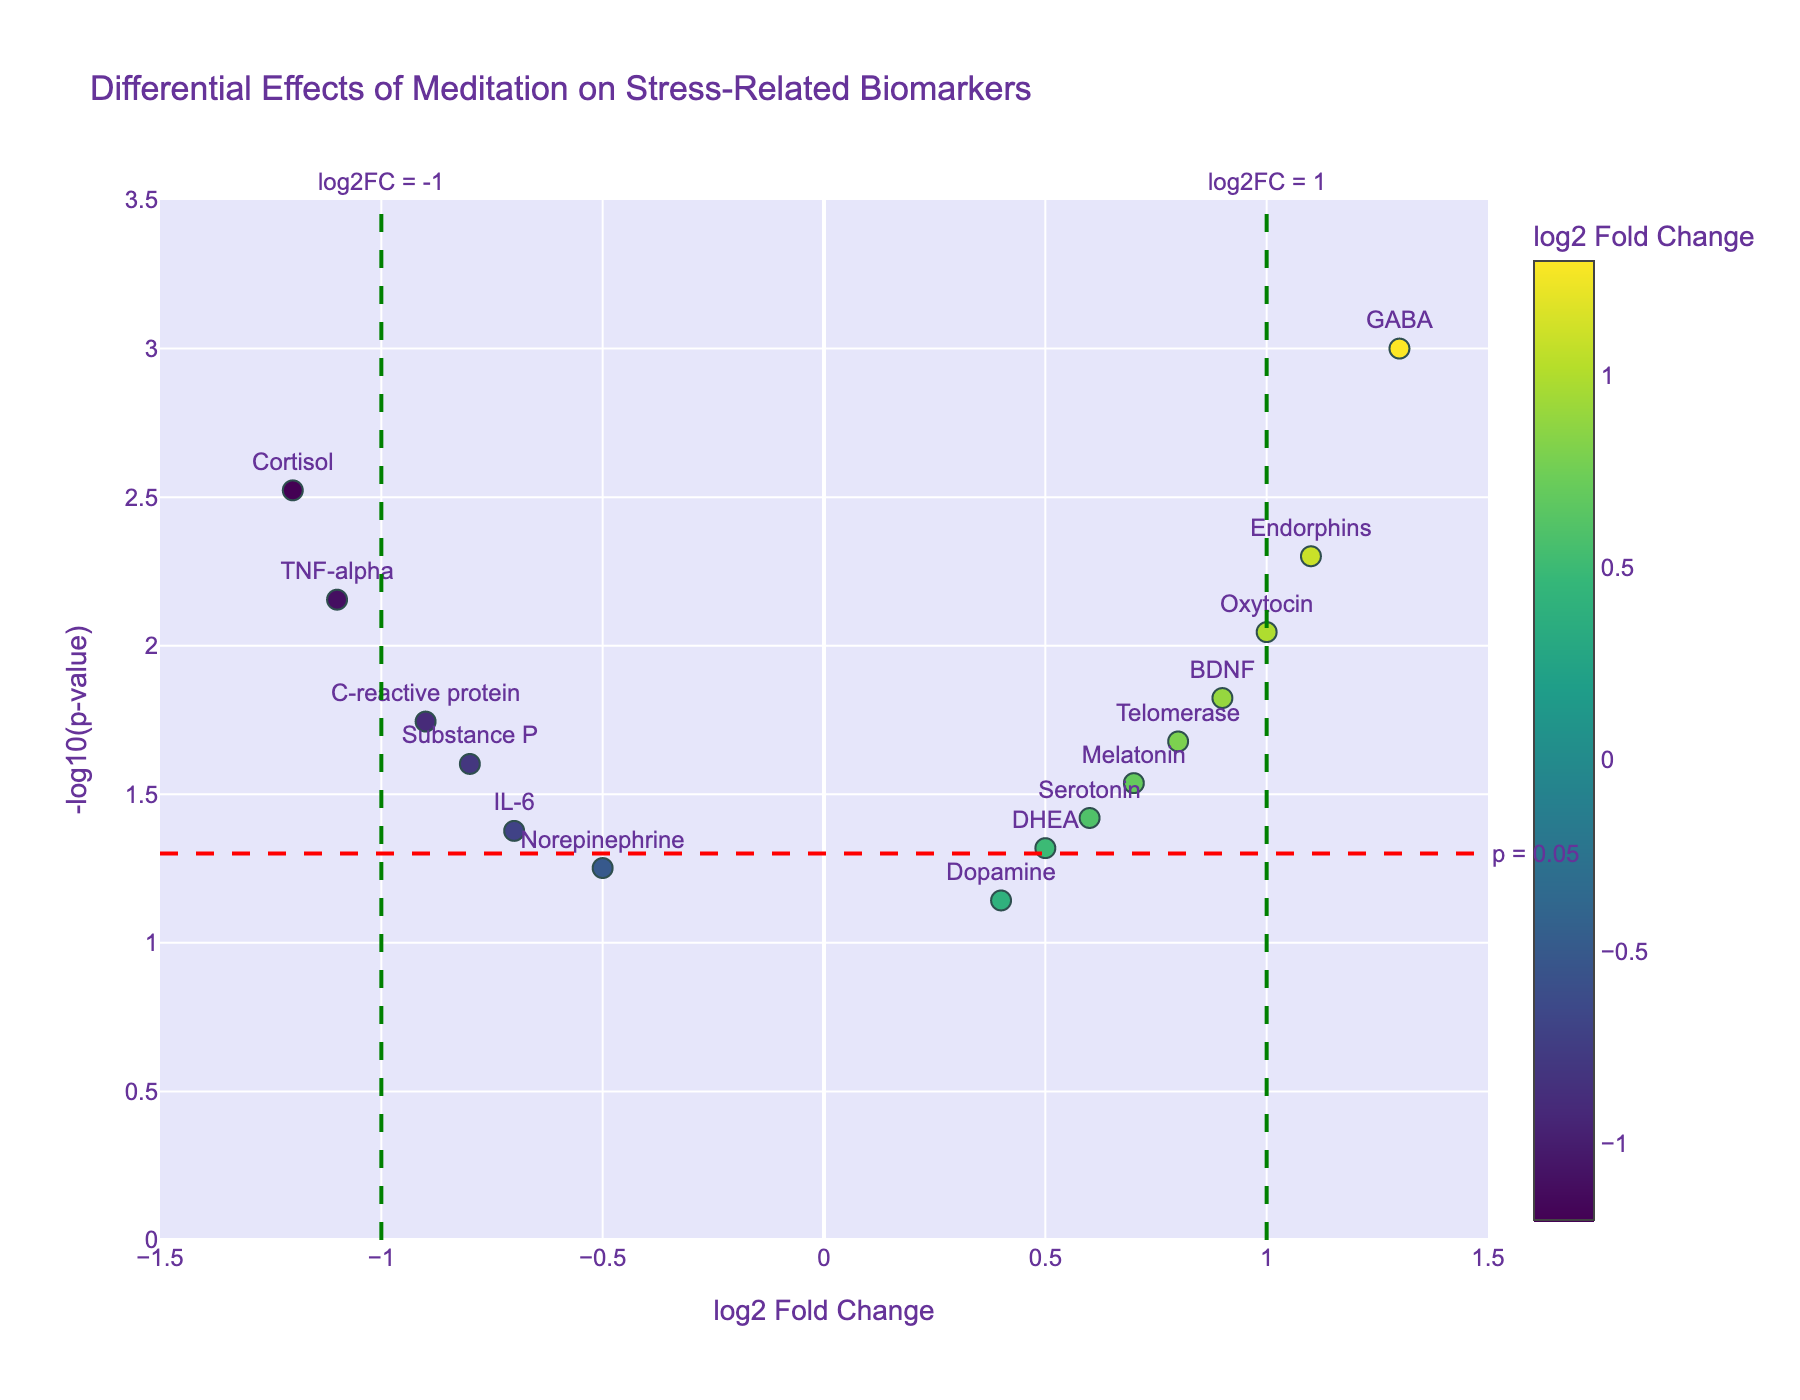Which biomarker has the highest log2 fold change? By looking at the x-axis labeled "log2 Fold Change," identify the data point that is farthest to the right. The highest value is 1.3.
Answer: GABA Which p-value threshold line is included in the plot? The horizontal red dashed line represents a p-value threshold. Since the y-axis is labeled "-log10(p-value)," we look for the line positioned around -log10(0.05).
Answer: 0.05 Which biomarkers have a log2 fold change greater than 1? To find the biomarkers with a log2 fold change greater than 1, check the right side of the vertical green dashed line at x=1. There are two points on the right side.
Answer: GABA, Endorphins What is the relationship between IL-6 and TNF-alpha in terms of log2 fold change and p-value? Compare the x and y coordinates of "IL-6" and "TNF-alpha". IL-6 has -0.7 for log2 fold change and 0.042 for p-value, while TNF-alpha has -1.1 for log2 fold change and 0.007 for p-value.
Answer: IL-6 has a higher log2 fold change and p-value than TNF-alpha Which biomarkers show a significant reduction with meditation (log2 fold change < -1 and p-value < 0.05)? To determine the biomarkers with log2 fold change less than -1 and p-value less than 0.05, look at the lower left side near the vertical and horizontal threshold lines.
Answer: Cortisol, TNF-alpha Is there any biomarker with a positive log2 fold change and p-value less than 0.01? Check the values on the right side (positive log2 fold change) and y-axis above -log10(0.01). There's one biomarker with a positive log2 fold change and a p-value less than 0.01.
Answer: GABA 